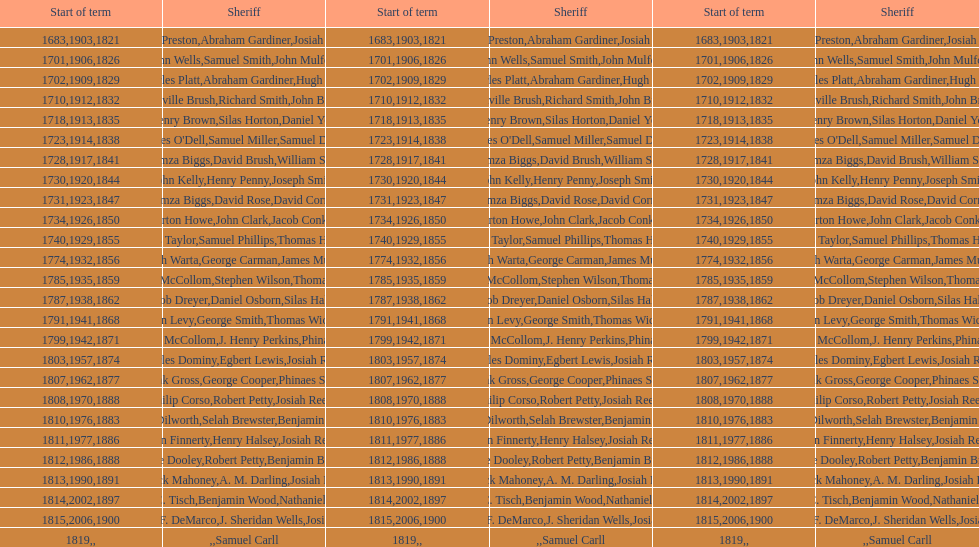What is the total number of sheriffs that were in office in suffolk county between 1903 and 1957? 17. 